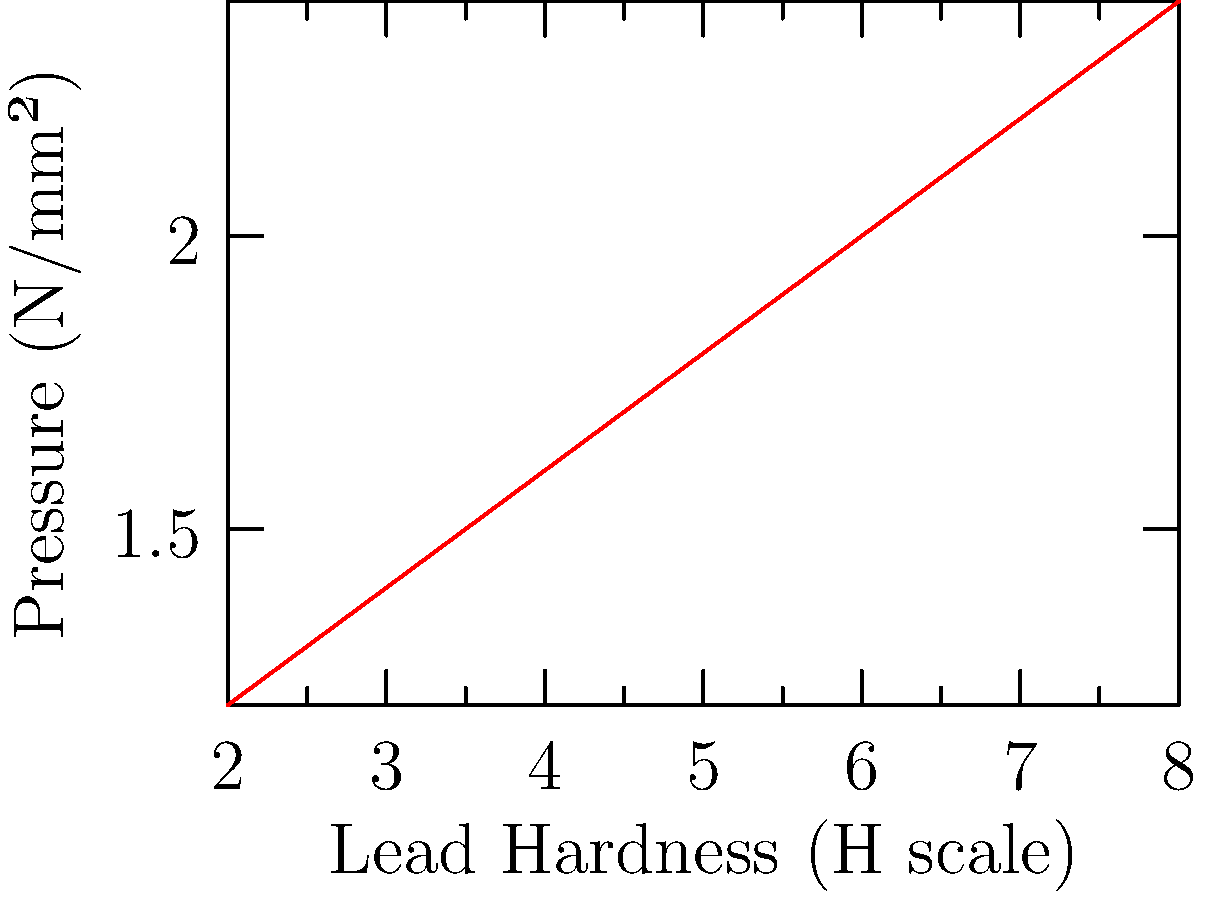As an art supply expert, you're analyzing the pressure exerted by different pencil lead hardnesses on paper. The graph shows the relationship between lead hardness (H scale) and pressure (N/mm²). Based on this data, what would be the approximate pressure exerted by a 5H pencil? To solve this problem, we need to follow these steps:

1. Understand the graph:
   - X-axis represents lead hardness (H scale)
   - Y-axis represents pressure (N/mm²)
   - The graph shows a linear relationship

2. Identify the known data points:
   - 2H: 1.2 N/mm²
   - 4H: 1.6 N/mm²
   - 6H: 2.0 N/mm²
   - 8H: 2.4 N/mm²

3. Calculate the rate of change (slope) of pressure per unit of hardness:
   $$ \text{Slope} = \frac{\text{Change in pressure}}{\text{Change in hardness}} = \frac{2.4 - 1.2}{8 - 2} = \frac{1.2}{6} = 0.2 \text{ N/mm²/H} $$

4. Use the slope to estimate the pressure for 5H:
   - 5H is halfway between 4H and 6H
   - Pressure at 4H: 1.6 N/mm²
   - Increase in pressure from 4H to 5H: $0.2 \text{ N/mm²/H} \times 1\text{H} = 0.2 \text{ N/mm²}$
   - Estimated pressure at 5H: $1.6 \text{ N/mm²} + 0.2 \text{ N/mm²} = 1.8 \text{ N/mm²}$

Therefore, the approximate pressure exerted by a 5H pencil would be 1.8 N/mm².
Answer: 1.8 N/mm² 